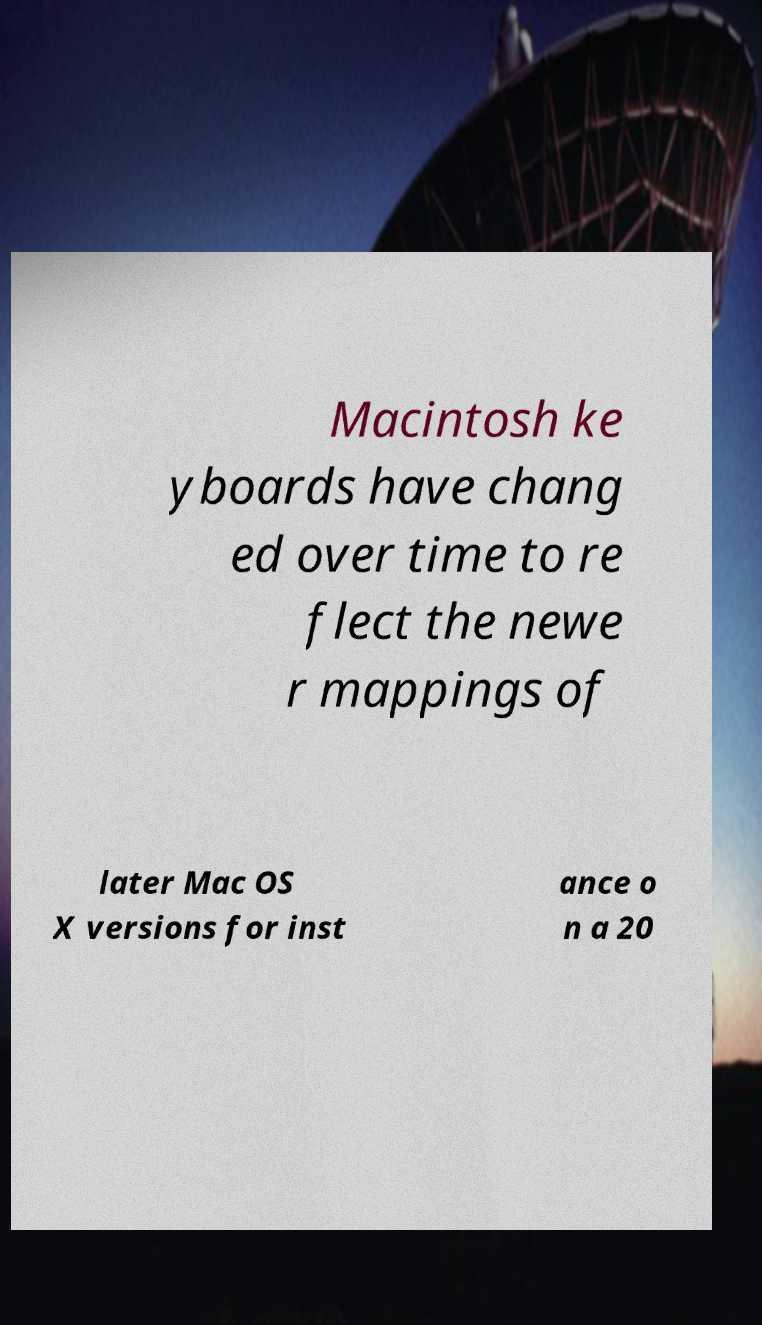Please identify and transcribe the text found in this image. Macintosh ke yboards have chang ed over time to re flect the newe r mappings of later Mac OS X versions for inst ance o n a 20 